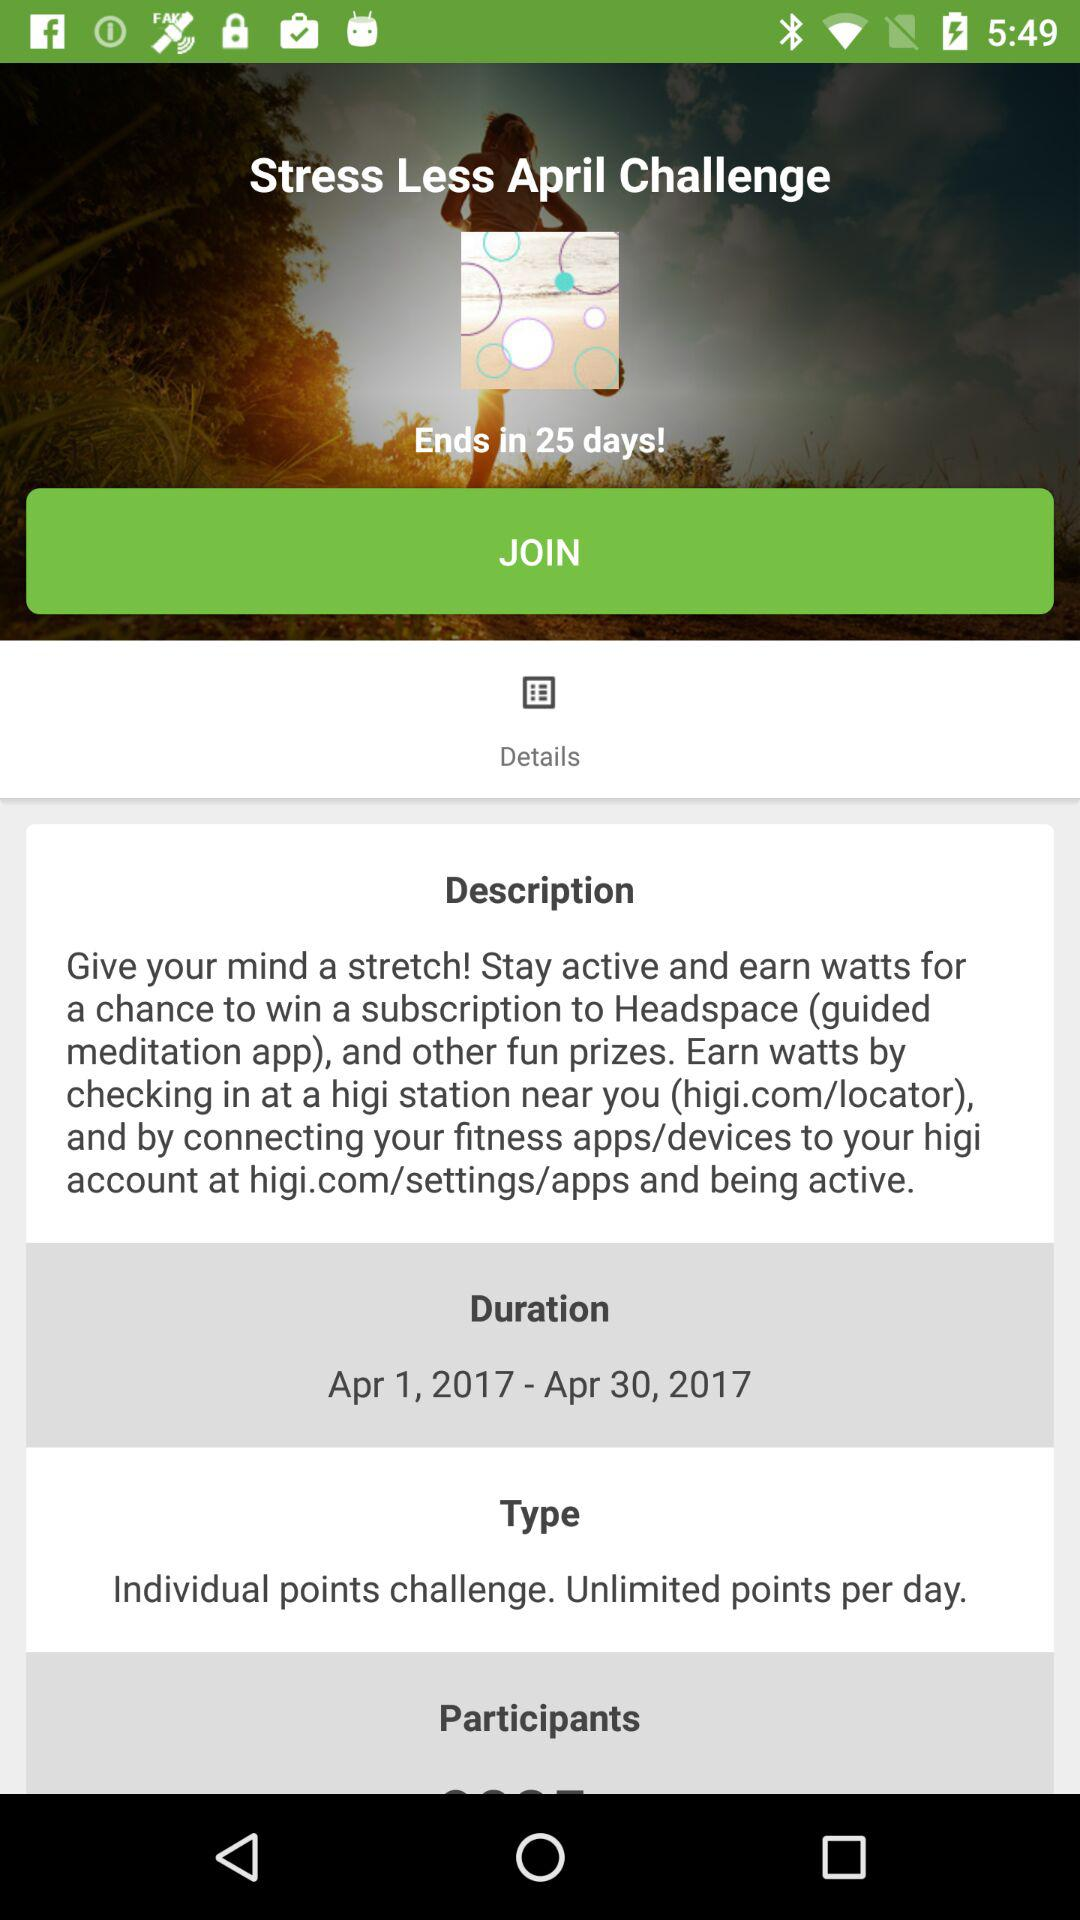How many points can be earned per day?
Answer the question using a single word or phrase. Unlimited 